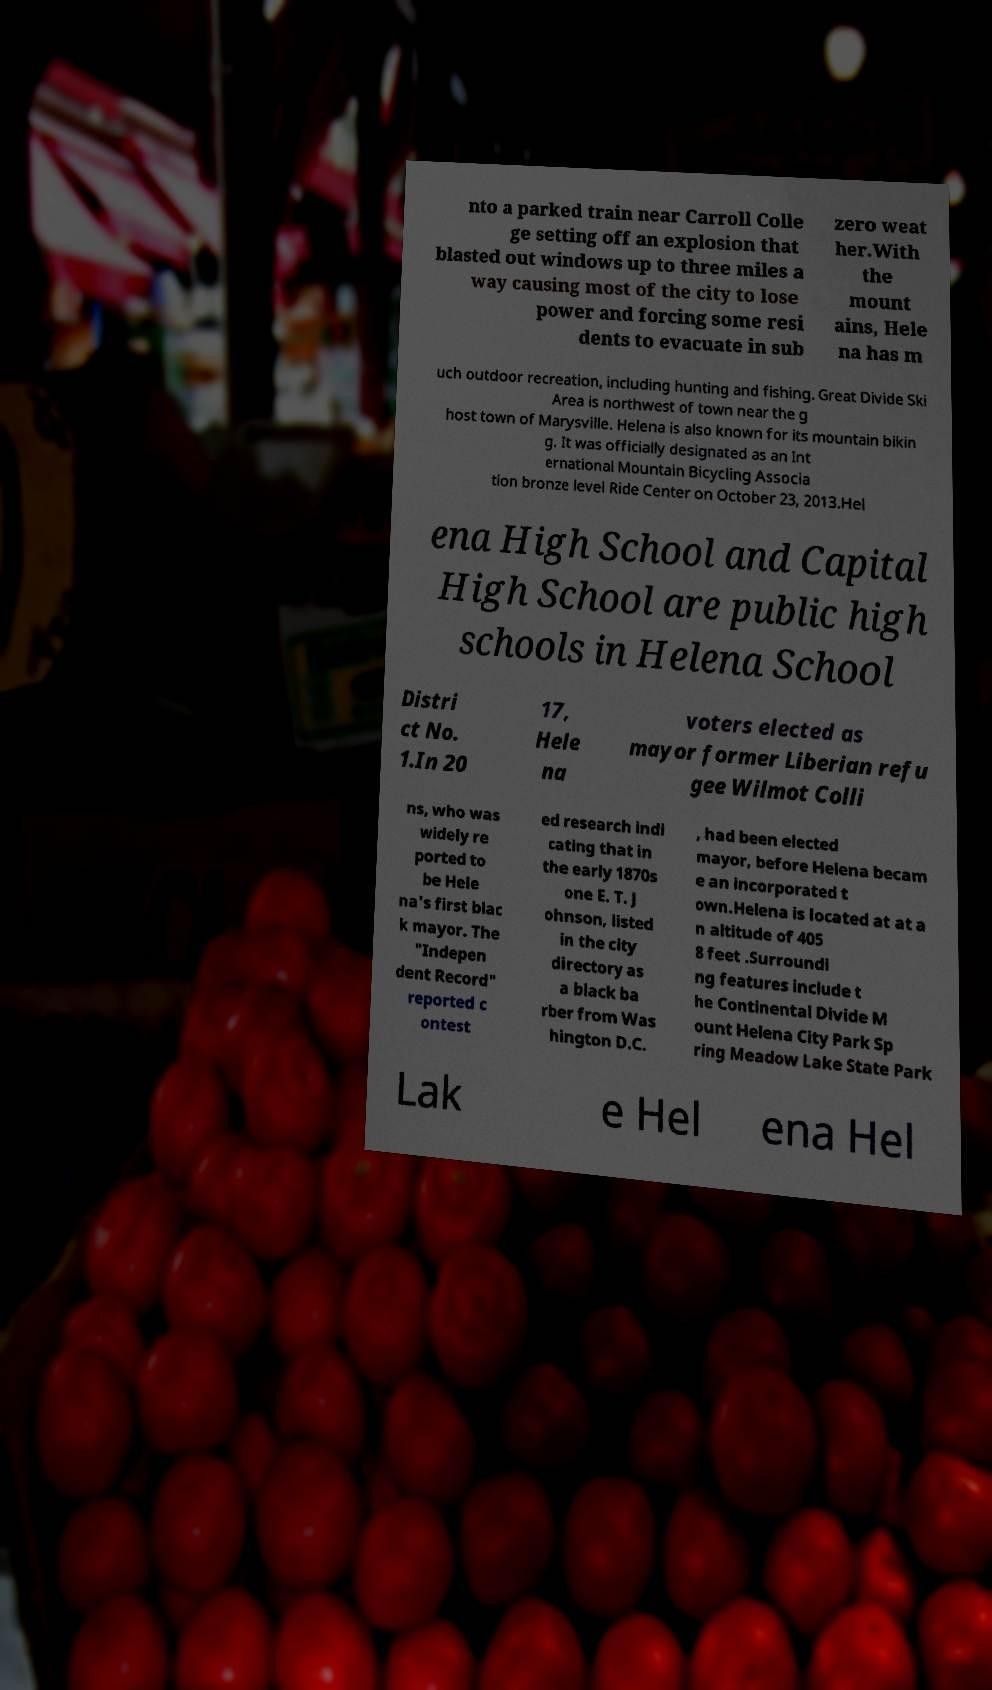Please read and relay the text visible in this image. What does it say? nto a parked train near Carroll Colle ge setting off an explosion that blasted out windows up to three miles a way causing most of the city to lose power and forcing some resi dents to evacuate in sub zero weat her.With the mount ains, Hele na has m uch outdoor recreation, including hunting and fishing. Great Divide Ski Area is northwest of town near the g host town of Marysville. Helena is also known for its mountain bikin g. It was officially designated as an Int ernational Mountain Bicycling Associa tion bronze level Ride Center on October 23, 2013.Hel ena High School and Capital High School are public high schools in Helena School Distri ct No. 1.In 20 17, Hele na voters elected as mayor former Liberian refu gee Wilmot Colli ns, who was widely re ported to be Hele na's first blac k mayor. The "Indepen dent Record" reported c ontest ed research indi cating that in the early 1870s one E. T. J ohnson, listed in the city directory as a black ba rber from Was hington D.C. , had been elected mayor, before Helena becam e an incorporated t own.Helena is located at at a n altitude of 405 8 feet .Surroundi ng features include t he Continental Divide M ount Helena City Park Sp ring Meadow Lake State Park Lak e Hel ena Hel 